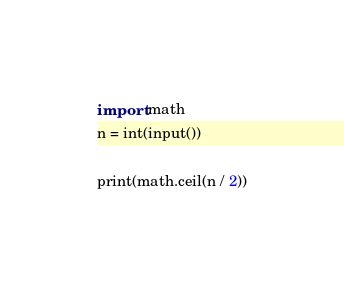Convert code to text. <code><loc_0><loc_0><loc_500><loc_500><_Python_>import math
n = int(input())

print(math.ceil(n / 2))
</code> 